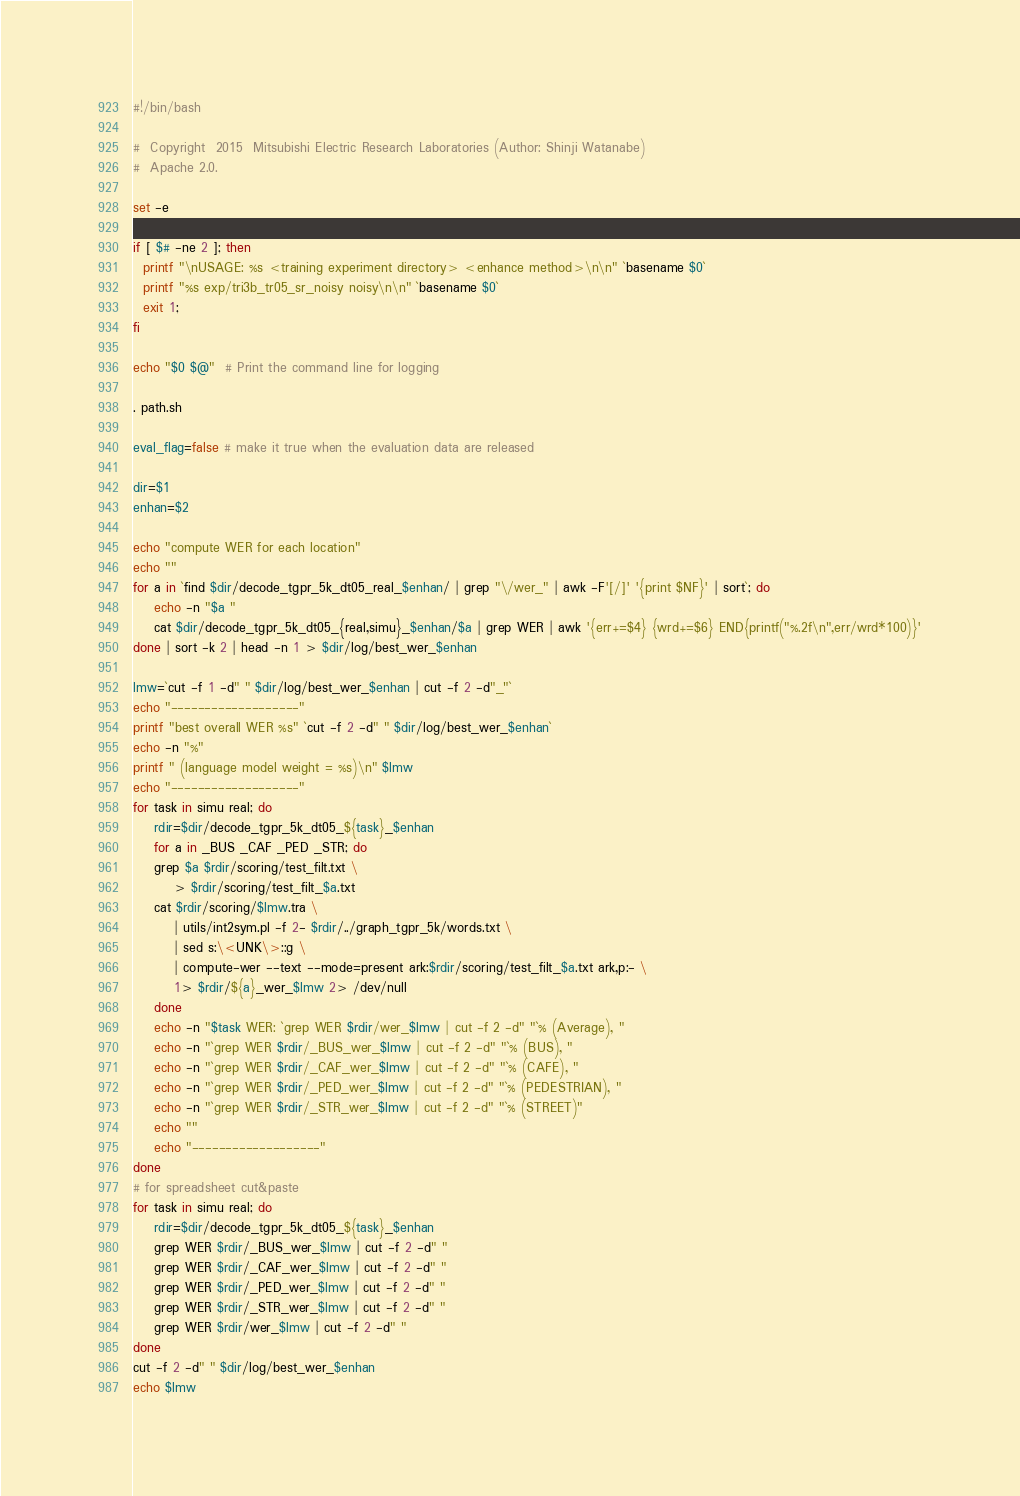Convert code to text. <code><loc_0><loc_0><loc_500><loc_500><_Bash_>#!/bin/bash

#  Copyright  2015  Mitsubishi Electric Research Laboratories (Author: Shinji Watanabe)
#  Apache 2.0.

set -e

if [ $# -ne 2 ]; then
  printf "\nUSAGE: %s <training experiment directory> <enhance method>\n\n" `basename $0`
  printf "%s exp/tri3b_tr05_sr_noisy noisy\n\n" `basename $0`
  exit 1;
fi

echo "$0 $@"  # Print the command line for logging

. path.sh

eval_flag=false # make it true when the evaluation data are released

dir=$1
enhan=$2

echo "compute WER for each location"
echo ""
for a in `find $dir/decode_tgpr_5k_dt05_real_$enhan/ | grep "\/wer_" | awk -F'[/]' '{print $NF}' | sort`; do
    echo -n "$a "
    cat $dir/decode_tgpr_5k_dt05_{real,simu}_$enhan/$a | grep WER | awk '{err+=$4} {wrd+=$6} END{printf("%.2f\n",err/wrd*100)}'
done | sort -k 2 | head -n 1 > $dir/log/best_wer_$enhan

lmw=`cut -f 1 -d" " $dir/log/best_wer_$enhan | cut -f 2 -d"_"`
echo "-------------------"
printf "best overall WER %s" `cut -f 2 -d" " $dir/log/best_wer_$enhan`
echo -n "%"
printf " (language model weight = %s)\n" $lmw
echo "-------------------"
for task in simu real; do
    rdir=$dir/decode_tgpr_5k_dt05_${task}_$enhan
    for a in _BUS _CAF _PED _STR; do
	grep $a $rdir/scoring/test_filt.txt \
	    > $rdir/scoring/test_filt_$a.txt
	cat $rdir/scoring/$lmw.tra \
	    | utils/int2sym.pl -f 2- $rdir/../graph_tgpr_5k/words.txt \
	    | sed s:\<UNK\>::g \
	    | compute-wer --text --mode=present ark:$rdir/scoring/test_filt_$a.txt ark,p:- \
	    1> $rdir/${a}_wer_$lmw 2> /dev/null
    done
    echo -n "$task WER: `grep WER $rdir/wer_$lmw | cut -f 2 -d" "`% (Average), "
    echo -n "`grep WER $rdir/_BUS_wer_$lmw | cut -f 2 -d" "`% (BUS), "
    echo -n "`grep WER $rdir/_CAF_wer_$lmw | cut -f 2 -d" "`% (CAFE), "
    echo -n "`grep WER $rdir/_PED_wer_$lmw | cut -f 2 -d" "`% (PEDESTRIAN), "
    echo -n "`grep WER $rdir/_STR_wer_$lmw | cut -f 2 -d" "`% (STREET)"
    echo ""
    echo "-------------------"
done
# for spreadsheet cut&paste
for task in simu real; do
    rdir=$dir/decode_tgpr_5k_dt05_${task}_$enhan
    grep WER $rdir/_BUS_wer_$lmw | cut -f 2 -d" "
    grep WER $rdir/_CAF_wer_$lmw | cut -f 2 -d" "
    grep WER $rdir/_PED_wer_$lmw | cut -f 2 -d" "
    grep WER $rdir/_STR_wer_$lmw | cut -f 2 -d" "
    grep WER $rdir/wer_$lmw | cut -f 2 -d" "
done
cut -f 2 -d" " $dir/log/best_wer_$enhan
echo $lmw
</code> 